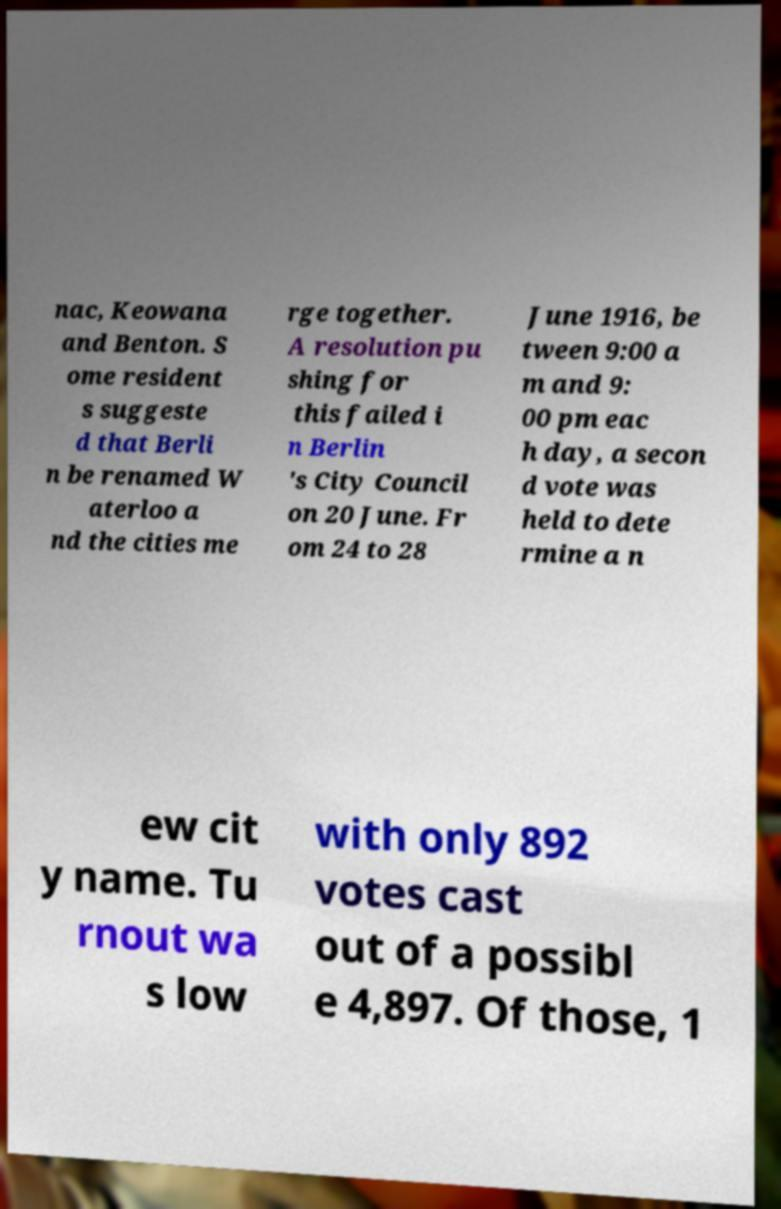Can you read and provide the text displayed in the image?This photo seems to have some interesting text. Can you extract and type it out for me? nac, Keowana and Benton. S ome resident s suggeste d that Berli n be renamed W aterloo a nd the cities me rge together. A resolution pu shing for this failed i n Berlin 's City Council on 20 June. Fr om 24 to 28 June 1916, be tween 9:00 a m and 9: 00 pm eac h day, a secon d vote was held to dete rmine a n ew cit y name. Tu rnout wa s low with only 892 votes cast out of a possibl e 4,897. Of those, 1 